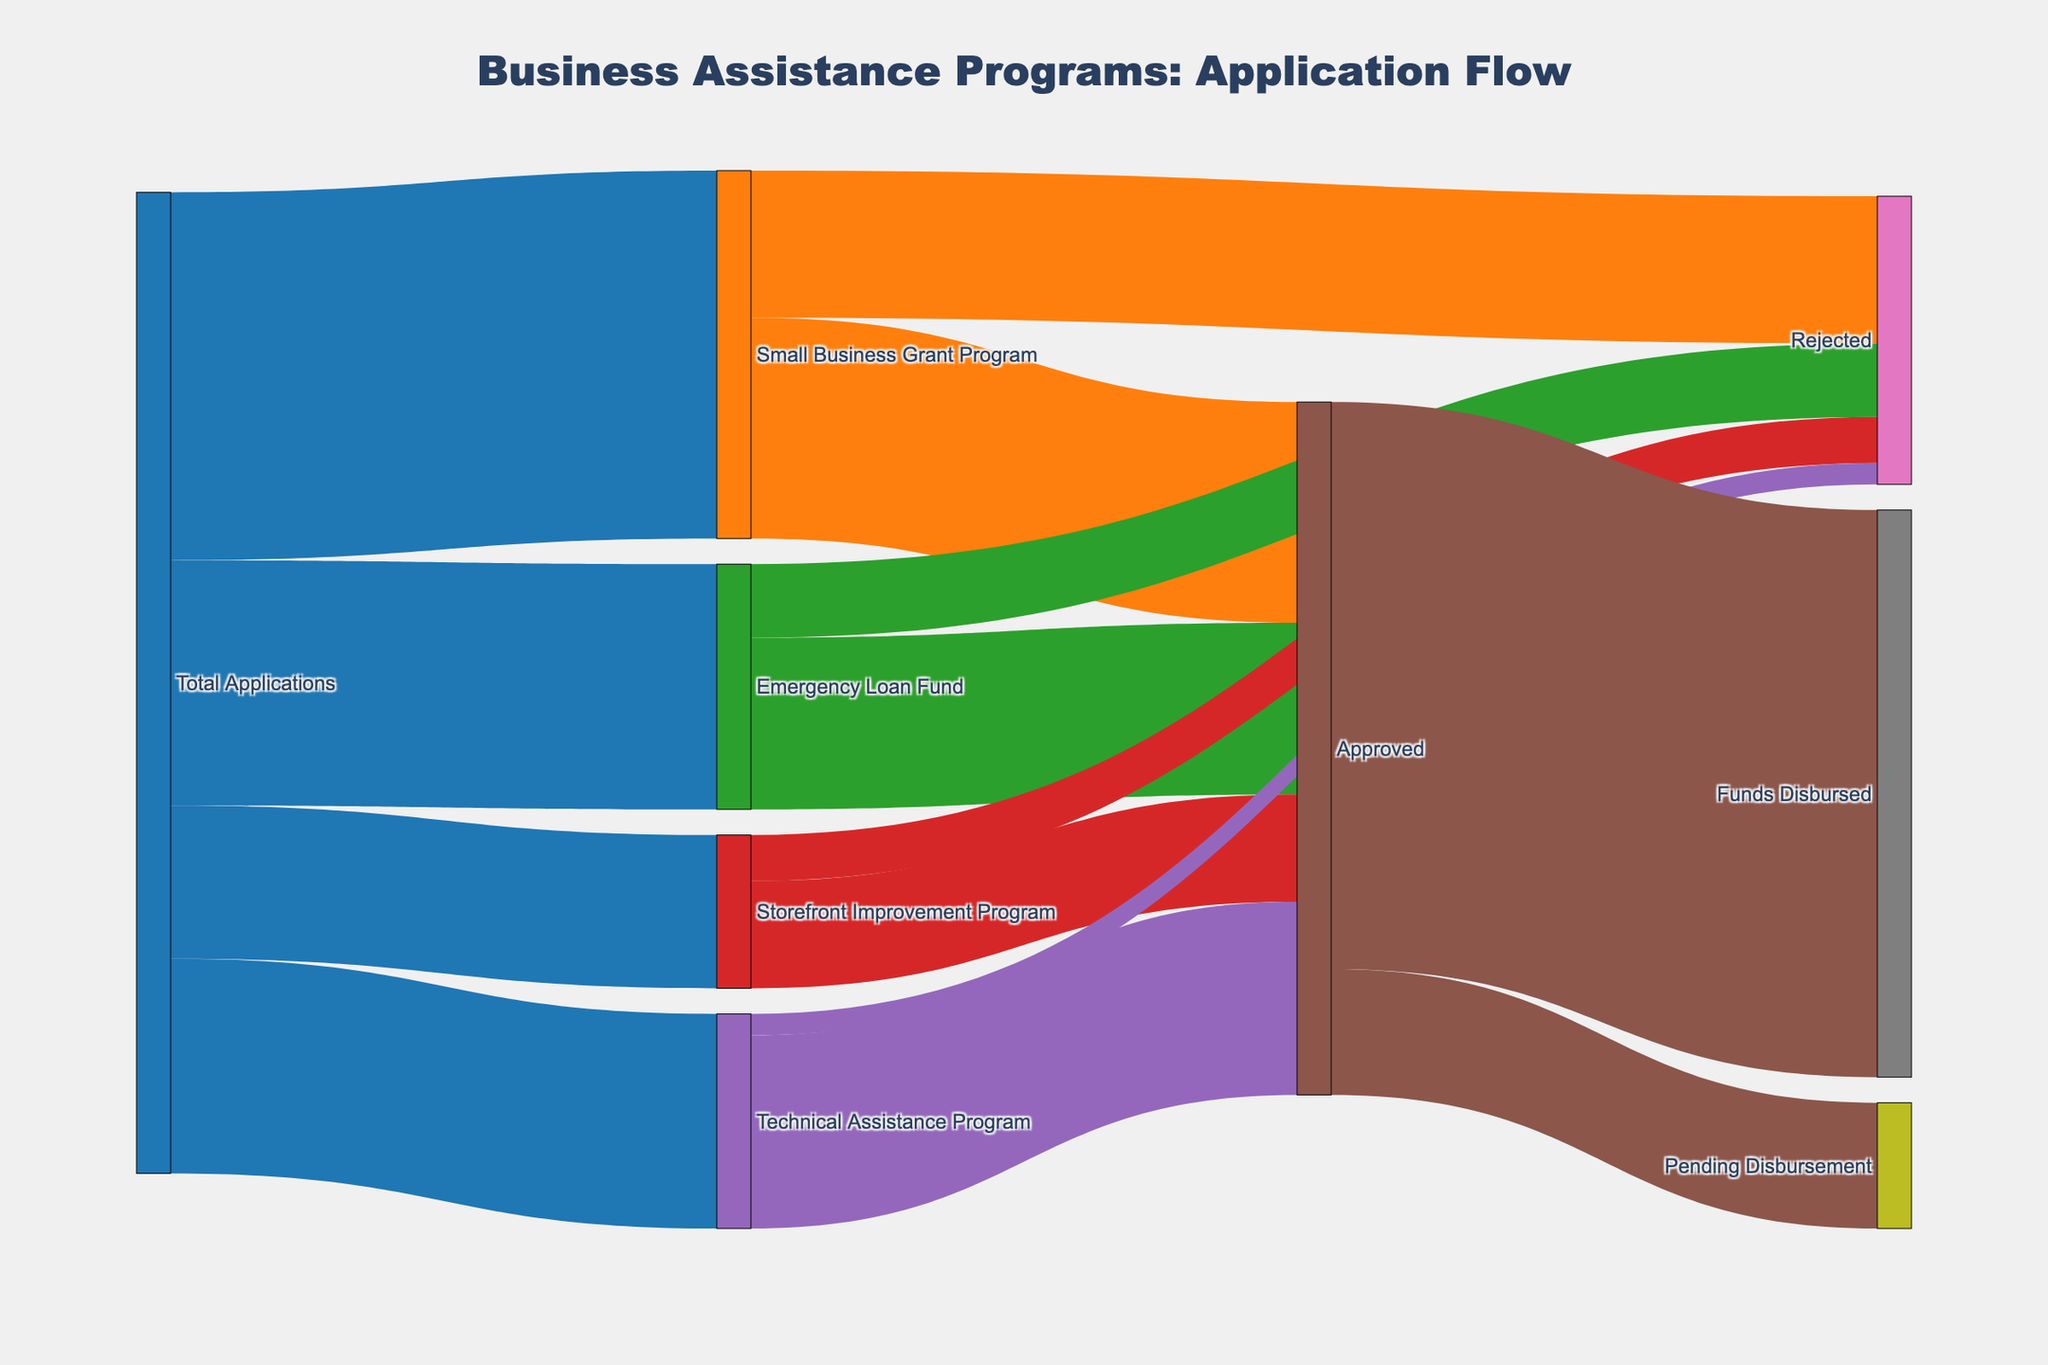what is the title of the diagram? The title can be found at the top of the diagram. It reads "Business Assistance Programs: Application Flow".
Answer: "Business Assistance Programs: Application Flow" how many applications were submitted in total? The total number of applications is listed as "Total Applications" leading into four different programs. Summing the values flowing into these programs (1200 + 800 + 500 + 700) equals 3200.
Answer: 3200 which business assistance program received the most applications? By comparing the values coming from "Total Applications" to each program, the "Small Business Grant Program" received the most with 1200 applications.
Answer: Small Business Grant Program what is the approval rate for the Storefront Improvement Program? The approval rate is calculated by dividing the number of approved applications by the total applications for that program. The Storefront Improvement Program had 350 approved out of 500 total, so the approval rate is \( \frac{350}{500} = 0.7 \) or 70%.
Answer: 70% how many applications were rejected across all programs? Sum the rejected applications from each program: (480 from Small Business Grant Program + 240 from Emergency Loan Fund + 150 from Storefront Improvement Program + 70 from Technical Assistance Program) = 940.
Answer: 940 is the number of approved applications greater for Emergency Loan Fund or Technical Assistance Program? Compare the approved applications for each: Emergency Loan Fund has 560 approved, and Technical Assistance Program has 630 approved. Technical Assistance Program is greater.
Answer: Technical Assistance Program how many approved applications are still pending disbursement? The count of approvals that are pending disbursement is shown as a subset of the "Approved" node leading to "Pending Disbursement", which is 410.
Answer: 410 what percentage of funds have been disbursed out of the total approved applications? To find the percentage of funds disbursed, divide the number of "Funds Disbursed" by the total approved applications, then multiply by 100. This gives \( \frac{1850}{2260} \times 100 \approx 81.86\% \).
Answer: 81.86% what proportion of applications for the Technical Assistance Program were rejected? The proportion of rejected applications is the number of rejected applications divided by the total applications for that program. For Technical Assistance Program, \( \frac{70}{700} = 0.1 \) or 10%.
Answer: 10% which node has the most connections coming from it? The "Total Applications" node has the most connections coming from it, leading into four different programs.
Answer: Total Applications 